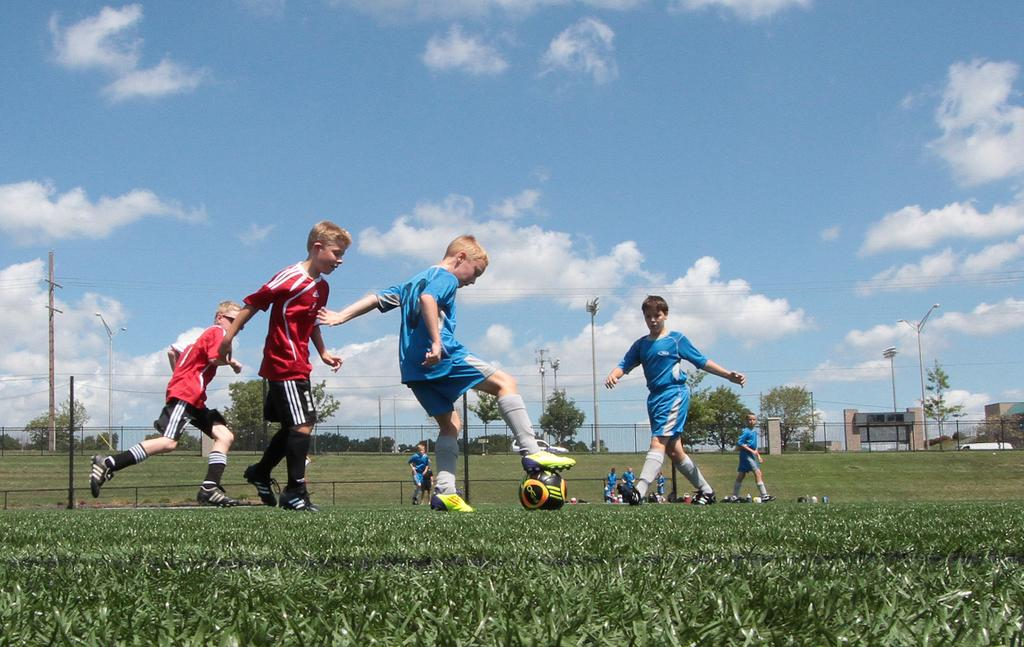What are the boys in the image doing? The boys are on the ground in the image. What object is under the feet of one of the boys? A football is under the feet of a boy. What can be seen in the background of the image? There are poles and the sky visible in the background of the image. How many giants can be seen in the image? There are no giants present in the image. What type of tooth is visible in the image? There is no tooth visible in the image. 